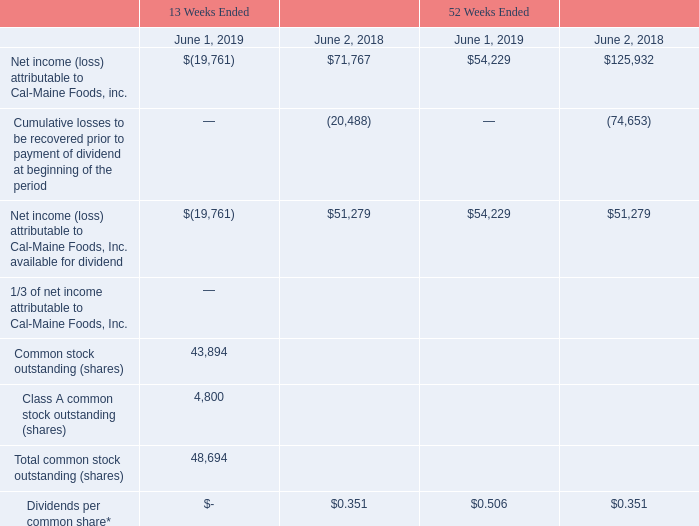Dividends
Cal-Maine pays a dividend to shareholders of its Common Stock and Class A Common Stock on a quarterly basis for each quarter for which the Company reports net income computed in accordance with generally accepted accounting principles in an amount equal to one-third (1/3) of such quarterly income. Dividends are paid to shareholders of record as of the 60th day following the last day of such quarter, except for the fourth fiscal quarter. For the fourth quarter, the Company will pay dividends to shareholders of record on the 65th day after the quarter end. Dividends are payable on the 15th day following the record date. Following a quarter for which the Company does not report net income, the Company will not pay a dividend for a subsequent profitable quarter until the Company is profitable on a cumulative basis computed from the date of the last quarter for which a dividend was paid. Dividends payable, which would represent accrued unpaid dividends applicable to the Company's fourth quarter, were zero at June 1, 2019 and $17.1 million at June 2, 2018. At June 1, 2019, cumulative losses that must be recovered prior to paying a dividend were $19.8 million.
*Dividends per common share = 1/3 of Net income (loss) attributable to Cal-Maine Foods, Inc. available for dividend ÷ Total common stock outstanding (shares).
What is the increase / (decrease) in the Net income (loss) attributable to Cal-Maine Foods, Inc. available for dividend in 2019 compared to 2018?
Answer scale should be: percent. $(19,761) / $51,279 - 1
Answer: -138.54. Except for the fourth fiscal year, on which day would the dividend be paid to the shareholders? 60th day following the last day of such quarter. What percentage of the class A common stock outstanding shares are a part of the total common stock outstanding shares?
Answer scale should be: percent. 4,800 / 48,694
Answer: 9.86. What was the dividend per common share in year ended June 2018? $0.351. In the year ended 2019, what is the dividend per common share? -. What is the dividend payout ration in year ending June 2018?
Answer scale should be: percent. (48,694 * 0.351) / 51,279
Answer: 33.33. 